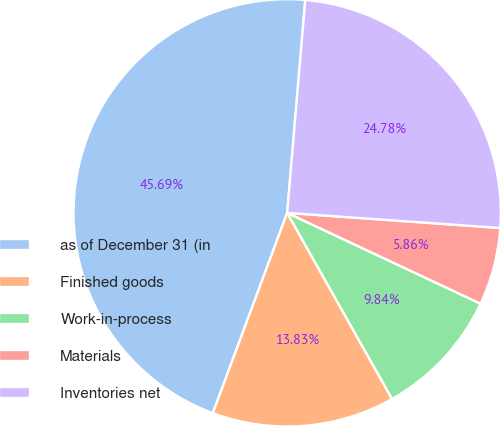<chart> <loc_0><loc_0><loc_500><loc_500><pie_chart><fcel>as of December 31 (in<fcel>Finished goods<fcel>Work-in-process<fcel>Materials<fcel>Inventories net<nl><fcel>45.69%<fcel>13.83%<fcel>9.84%<fcel>5.86%<fcel>24.78%<nl></chart> 